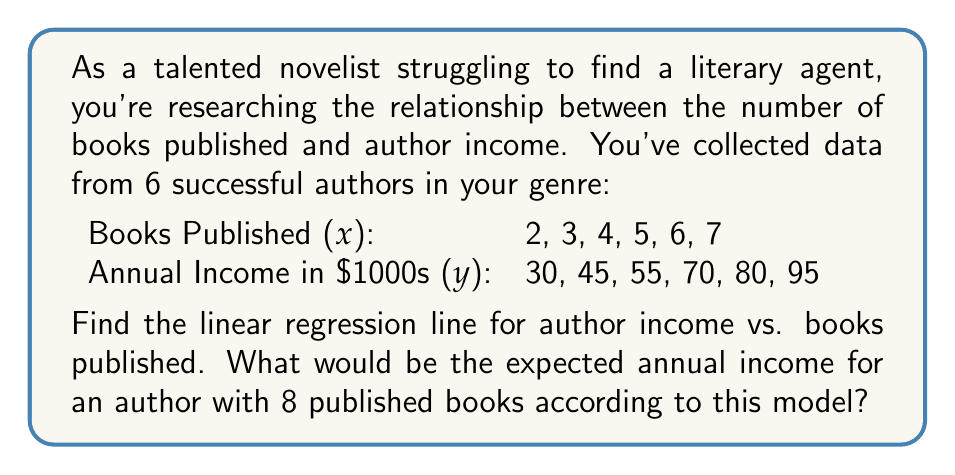Help me with this question. To find the linear regression line, we'll use the equation $y = mx + b$, where $m$ is the slope and $b$ is the y-intercept.

Step 1: Calculate the means of x and y.
$\bar{x} = \frac{2 + 3 + 4 + 5 + 6 + 7}{6} = 4.5$
$\bar{y} = \frac{30 + 45 + 55 + 70 + 80 + 95}{6} = 62.5$

Step 2: Calculate $\sum (x - \bar{x})(y - \bar{y})$ and $\sum (x - \bar{x})^2$.
$\sum (x - \bar{x})(y - \bar{y}) = 185$
$\sum (x - \bar{x})^2 = 17.5$

Step 3: Calculate the slope $m$.
$m = \frac{\sum (x - \bar{x})(y - \bar{y})}{\sum (x - \bar{x})^2} = \frac{185}{17.5} = 10.5714$

Step 4: Calculate the y-intercept $b$.
$b = \bar{y} - m\bar{x} = 62.5 - 10.5714 \cdot 4.5 = 15$

Step 5: Write the linear regression equation.
$y = 10.5714x + 15$

Step 6: Calculate the expected income for an author with 8 published books.
$y = 10.5714 \cdot 8 + 15 = 99.5712$
Answer: The linear regression line is $y = 10.5714x + 15$, where $x$ is the number of books published and $y$ is the annual income in thousands of dollars.

For an author with 8 published books, the expected annual income would be approximately $99,571. 